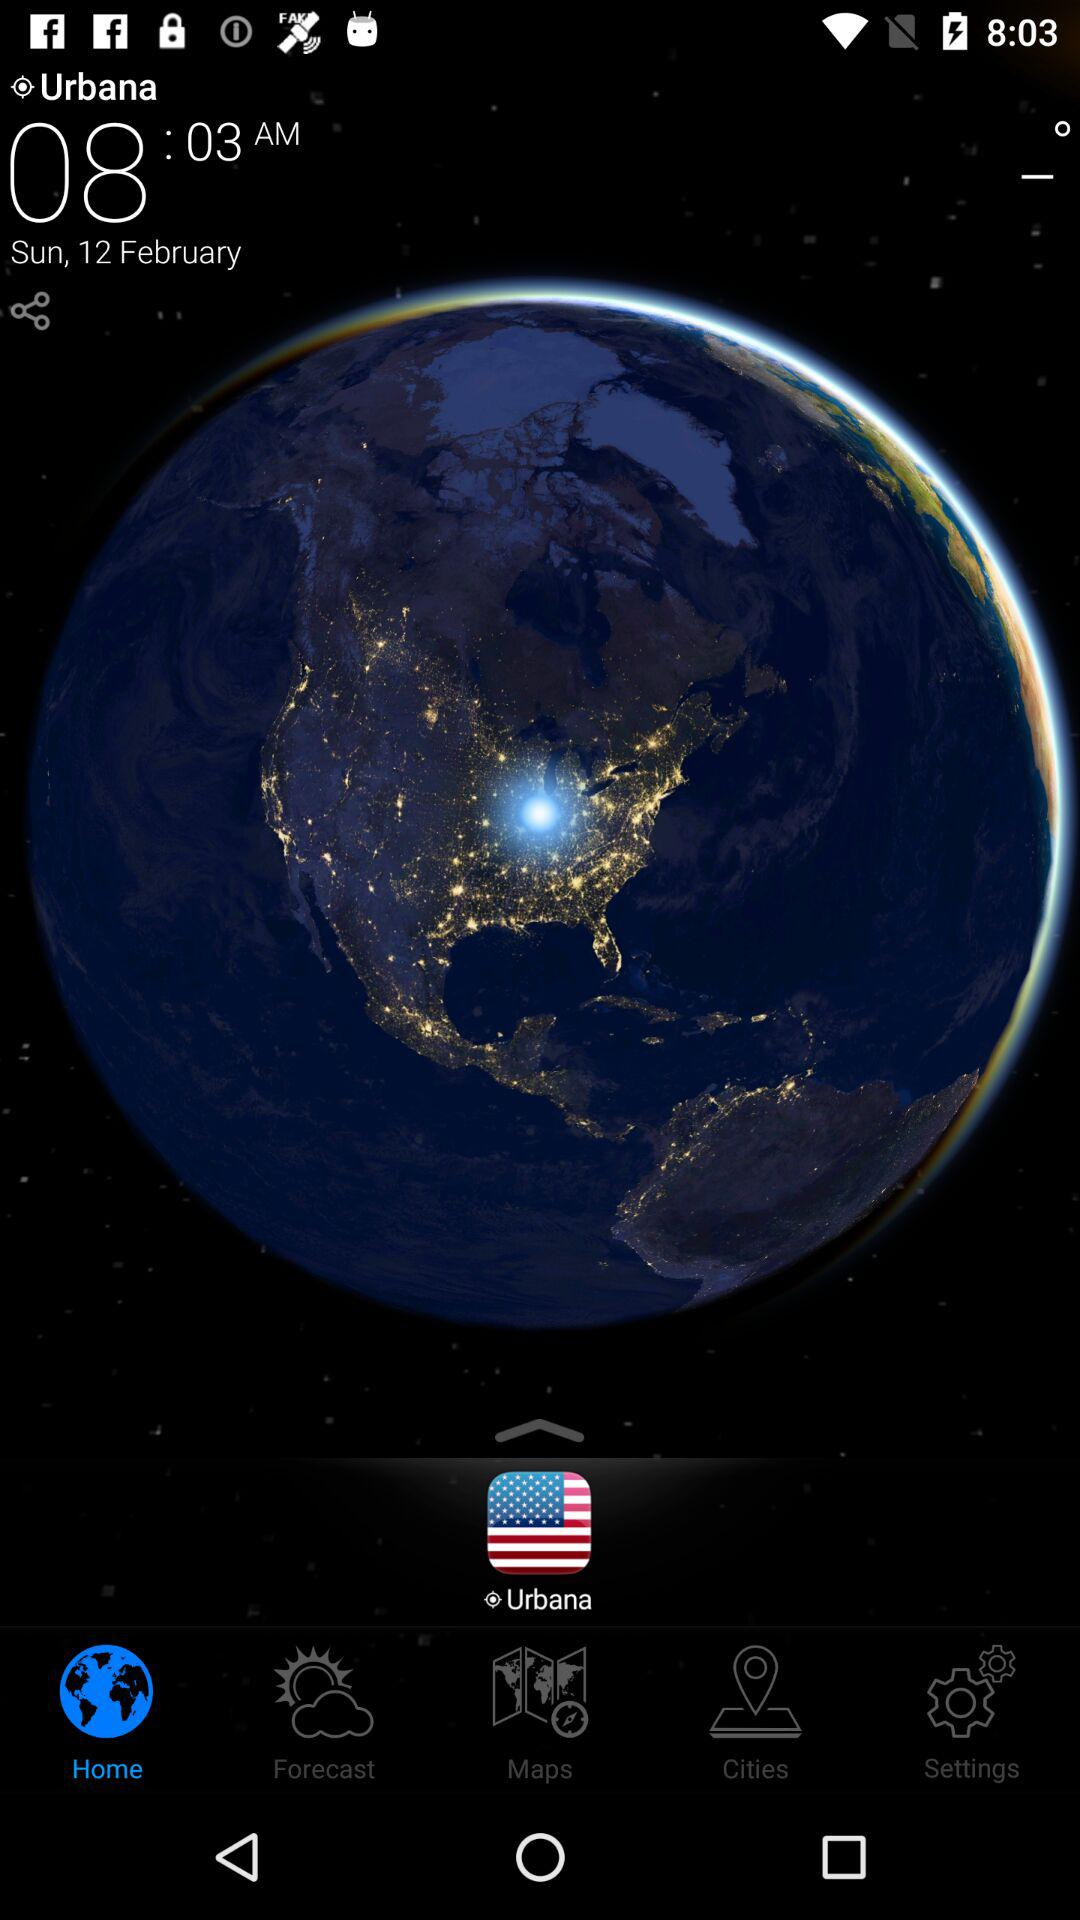Which tab is currently selected? The currently selected tab is "Home". 